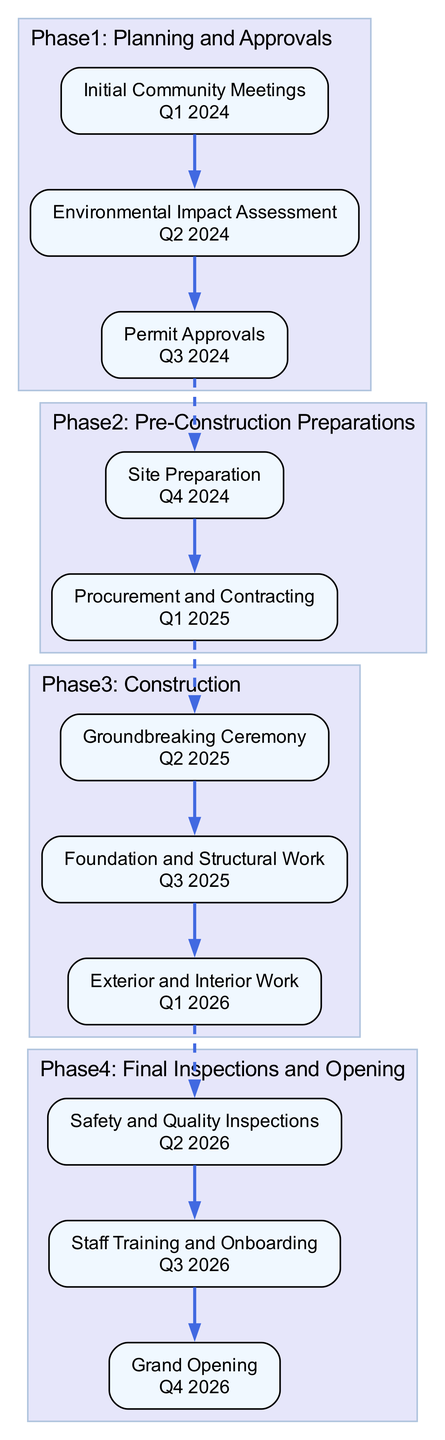What is the initial milestone in Phase 1? The first milestone in Phase 1 is "Initial Community Meetings" which appears as the top node in the Phase 1 cluster.
Answer: Initial Community Meetings How many phases are there in the construction timeline? By counting the subgraphs that represent each phase, we find there are a total of 4 phases in the timeline.
Answer: 4 What is the date for the Grand Opening milestone? The Grand Opening milestone is located at the end of Phase 4 and is labeled with the date "Q4 2026".
Answer: Q4 2026 Which milestone follows the Safety and Quality Inspections in Phase 4? The milestone that follows Safety and Quality Inspections is "Staff Training and Onboarding", which is the second milestone in Phase 4.
Answer: Staff Training and Onboarding Which phase includes the Groundbreaking Ceremony? The Groundbreaking Ceremony is a milestone in Phase 3, as indicated by its placement within that cluster.
Answer: Phase 3 What links Phase 2 to Phase 3? A dashed edge connects the last milestone of Phase 2, "Procurement and Contracting", to the first milestone of Phase 3, "Groundbreaking Ceremony", indicating the transition between these phases.
Answer: A dashed edge What is the total number of milestones in Phase 3? Counting the number of nodes within Phase 3, we find that there are 3 milestones: Groundbreaking Ceremony, Foundation and Structural Work, and Exterior and Interior Work.
Answer: 3 